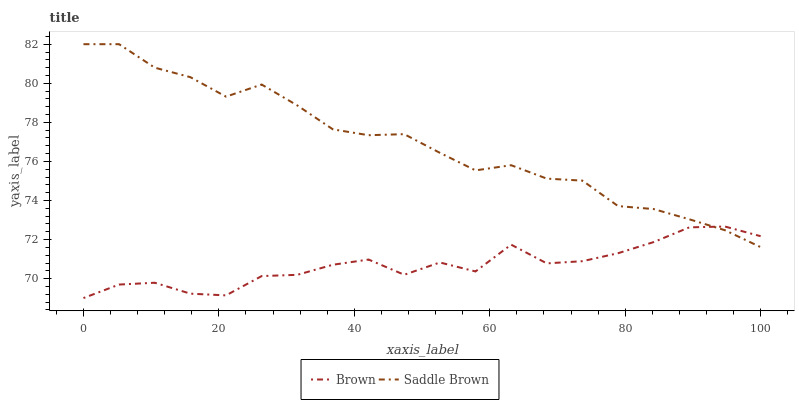Does Brown have the minimum area under the curve?
Answer yes or no. Yes. Does Saddle Brown have the maximum area under the curve?
Answer yes or no. Yes. Does Saddle Brown have the minimum area under the curve?
Answer yes or no. No. Is Saddle Brown the smoothest?
Answer yes or no. Yes. Is Brown the roughest?
Answer yes or no. Yes. Is Saddle Brown the roughest?
Answer yes or no. No. Does Brown have the lowest value?
Answer yes or no. Yes. Does Saddle Brown have the lowest value?
Answer yes or no. No. Does Saddle Brown have the highest value?
Answer yes or no. Yes. Does Brown intersect Saddle Brown?
Answer yes or no. Yes. Is Brown less than Saddle Brown?
Answer yes or no. No. Is Brown greater than Saddle Brown?
Answer yes or no. No. 